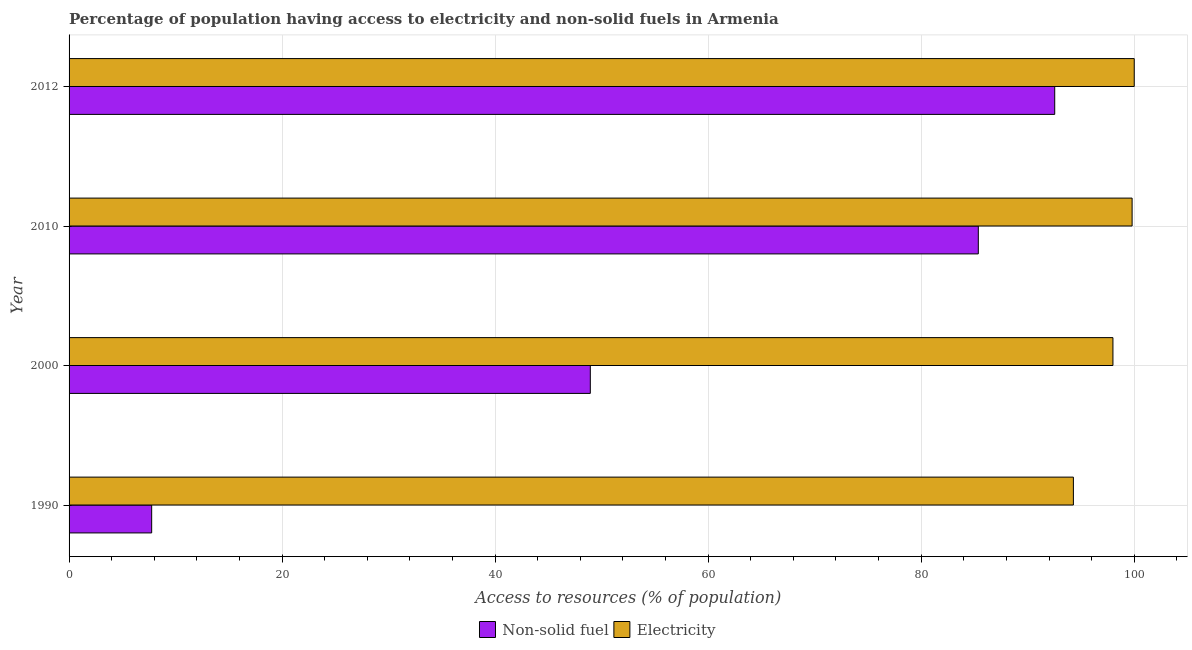How many different coloured bars are there?
Keep it short and to the point. 2. Are the number of bars per tick equal to the number of legend labels?
Keep it short and to the point. Yes. Are the number of bars on each tick of the Y-axis equal?
Make the answer very short. Yes. How many bars are there on the 3rd tick from the top?
Provide a succinct answer. 2. How many bars are there on the 1st tick from the bottom?
Offer a terse response. 2. What is the label of the 3rd group of bars from the top?
Provide a short and direct response. 2000. What is the percentage of population having access to electricity in 2012?
Your answer should be compact. 100. Across all years, what is the minimum percentage of population having access to electricity?
Offer a very short reply. 94.29. What is the total percentage of population having access to electricity in the graph?
Provide a succinct answer. 392.09. What is the difference between the percentage of population having access to non-solid fuel in 1990 and that in 2010?
Offer a terse response. -77.61. What is the difference between the percentage of population having access to non-solid fuel in 2012 and the percentage of population having access to electricity in 1990?
Provide a short and direct response. -1.75. What is the average percentage of population having access to non-solid fuel per year?
Give a very brief answer. 58.65. In the year 1990, what is the difference between the percentage of population having access to electricity and percentage of population having access to non-solid fuel?
Make the answer very short. 86.53. What is the ratio of the percentage of population having access to electricity in 1990 to that in 2012?
Offer a very short reply. 0.94. Is the percentage of population having access to electricity in 1990 less than that in 2012?
Keep it short and to the point. Yes. What is the difference between the highest and the lowest percentage of population having access to non-solid fuel?
Provide a short and direct response. 84.78. In how many years, is the percentage of population having access to electricity greater than the average percentage of population having access to electricity taken over all years?
Provide a short and direct response. 2. What does the 1st bar from the top in 2000 represents?
Offer a very short reply. Electricity. What does the 2nd bar from the bottom in 2010 represents?
Keep it short and to the point. Electricity. Are all the bars in the graph horizontal?
Offer a very short reply. Yes. What is the difference between two consecutive major ticks on the X-axis?
Provide a short and direct response. 20. Are the values on the major ticks of X-axis written in scientific E-notation?
Provide a short and direct response. No. Does the graph contain any zero values?
Give a very brief answer. No. How many legend labels are there?
Offer a terse response. 2. What is the title of the graph?
Offer a terse response. Percentage of population having access to electricity and non-solid fuels in Armenia. Does "Passenger Transport Items" appear as one of the legend labels in the graph?
Your answer should be compact. No. What is the label or title of the X-axis?
Your answer should be compact. Access to resources (% of population). What is the Access to resources (% of population) of Non-solid fuel in 1990?
Offer a very short reply. 7.75. What is the Access to resources (% of population) of Electricity in 1990?
Offer a very short reply. 94.29. What is the Access to resources (% of population) of Non-solid fuel in 2000?
Your response must be concise. 48.94. What is the Access to resources (% of population) of Non-solid fuel in 2010?
Make the answer very short. 85.36. What is the Access to resources (% of population) in Electricity in 2010?
Keep it short and to the point. 99.8. What is the Access to resources (% of population) of Non-solid fuel in 2012?
Provide a succinct answer. 92.53. What is the Access to resources (% of population) of Electricity in 2012?
Provide a succinct answer. 100. Across all years, what is the maximum Access to resources (% of population) in Non-solid fuel?
Your answer should be very brief. 92.53. Across all years, what is the maximum Access to resources (% of population) in Electricity?
Provide a succinct answer. 100. Across all years, what is the minimum Access to resources (% of population) of Non-solid fuel?
Offer a terse response. 7.75. Across all years, what is the minimum Access to resources (% of population) of Electricity?
Ensure brevity in your answer.  94.29. What is the total Access to resources (% of population) in Non-solid fuel in the graph?
Ensure brevity in your answer.  234.59. What is the total Access to resources (% of population) of Electricity in the graph?
Your answer should be compact. 392.09. What is the difference between the Access to resources (% of population) of Non-solid fuel in 1990 and that in 2000?
Keep it short and to the point. -41.18. What is the difference between the Access to resources (% of population) of Electricity in 1990 and that in 2000?
Your answer should be very brief. -3.71. What is the difference between the Access to resources (% of population) in Non-solid fuel in 1990 and that in 2010?
Make the answer very short. -77.61. What is the difference between the Access to resources (% of population) in Electricity in 1990 and that in 2010?
Give a very brief answer. -5.51. What is the difference between the Access to resources (% of population) of Non-solid fuel in 1990 and that in 2012?
Your response must be concise. -84.78. What is the difference between the Access to resources (% of population) of Electricity in 1990 and that in 2012?
Your answer should be compact. -5.71. What is the difference between the Access to resources (% of population) of Non-solid fuel in 2000 and that in 2010?
Provide a short and direct response. -36.43. What is the difference between the Access to resources (% of population) of Non-solid fuel in 2000 and that in 2012?
Your answer should be compact. -43.6. What is the difference between the Access to resources (% of population) in Electricity in 2000 and that in 2012?
Keep it short and to the point. -2. What is the difference between the Access to resources (% of population) of Non-solid fuel in 2010 and that in 2012?
Provide a short and direct response. -7.17. What is the difference between the Access to resources (% of population) of Electricity in 2010 and that in 2012?
Your answer should be very brief. -0.2. What is the difference between the Access to resources (% of population) in Non-solid fuel in 1990 and the Access to resources (% of population) in Electricity in 2000?
Give a very brief answer. -90.25. What is the difference between the Access to resources (% of population) of Non-solid fuel in 1990 and the Access to resources (% of population) of Electricity in 2010?
Your answer should be compact. -92.05. What is the difference between the Access to resources (% of population) in Non-solid fuel in 1990 and the Access to resources (% of population) in Electricity in 2012?
Offer a terse response. -92.25. What is the difference between the Access to resources (% of population) of Non-solid fuel in 2000 and the Access to resources (% of population) of Electricity in 2010?
Provide a short and direct response. -50.86. What is the difference between the Access to resources (% of population) in Non-solid fuel in 2000 and the Access to resources (% of population) in Electricity in 2012?
Offer a very short reply. -51.06. What is the difference between the Access to resources (% of population) of Non-solid fuel in 2010 and the Access to resources (% of population) of Electricity in 2012?
Offer a very short reply. -14.64. What is the average Access to resources (% of population) of Non-solid fuel per year?
Provide a short and direct response. 58.65. What is the average Access to resources (% of population) of Electricity per year?
Give a very brief answer. 98.02. In the year 1990, what is the difference between the Access to resources (% of population) in Non-solid fuel and Access to resources (% of population) in Electricity?
Make the answer very short. -86.53. In the year 2000, what is the difference between the Access to resources (% of population) of Non-solid fuel and Access to resources (% of population) of Electricity?
Give a very brief answer. -49.06. In the year 2010, what is the difference between the Access to resources (% of population) of Non-solid fuel and Access to resources (% of population) of Electricity?
Your answer should be very brief. -14.44. In the year 2012, what is the difference between the Access to resources (% of population) in Non-solid fuel and Access to resources (% of population) in Electricity?
Keep it short and to the point. -7.47. What is the ratio of the Access to resources (% of population) in Non-solid fuel in 1990 to that in 2000?
Give a very brief answer. 0.16. What is the ratio of the Access to resources (% of population) of Electricity in 1990 to that in 2000?
Offer a terse response. 0.96. What is the ratio of the Access to resources (% of population) of Non-solid fuel in 1990 to that in 2010?
Keep it short and to the point. 0.09. What is the ratio of the Access to resources (% of population) of Electricity in 1990 to that in 2010?
Ensure brevity in your answer.  0.94. What is the ratio of the Access to resources (% of population) in Non-solid fuel in 1990 to that in 2012?
Your answer should be very brief. 0.08. What is the ratio of the Access to resources (% of population) of Electricity in 1990 to that in 2012?
Your response must be concise. 0.94. What is the ratio of the Access to resources (% of population) in Non-solid fuel in 2000 to that in 2010?
Provide a succinct answer. 0.57. What is the ratio of the Access to resources (% of population) of Non-solid fuel in 2000 to that in 2012?
Make the answer very short. 0.53. What is the ratio of the Access to resources (% of population) in Non-solid fuel in 2010 to that in 2012?
Provide a succinct answer. 0.92. What is the difference between the highest and the second highest Access to resources (% of population) in Non-solid fuel?
Provide a short and direct response. 7.17. What is the difference between the highest and the lowest Access to resources (% of population) of Non-solid fuel?
Provide a short and direct response. 84.78. What is the difference between the highest and the lowest Access to resources (% of population) in Electricity?
Give a very brief answer. 5.71. 